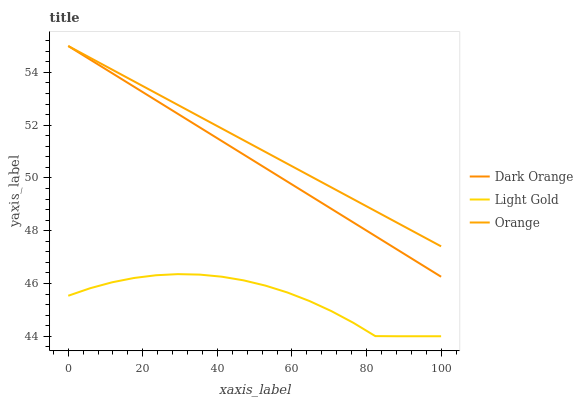Does Light Gold have the minimum area under the curve?
Answer yes or no. Yes. Does Orange have the maximum area under the curve?
Answer yes or no. Yes. Does Dark Orange have the minimum area under the curve?
Answer yes or no. No. Does Dark Orange have the maximum area under the curve?
Answer yes or no. No. Is Orange the smoothest?
Answer yes or no. Yes. Is Light Gold the roughest?
Answer yes or no. Yes. Is Dark Orange the smoothest?
Answer yes or no. No. Is Dark Orange the roughest?
Answer yes or no. No. Does Light Gold have the lowest value?
Answer yes or no. Yes. Does Dark Orange have the lowest value?
Answer yes or no. No. Does Dark Orange have the highest value?
Answer yes or no. Yes. Does Light Gold have the highest value?
Answer yes or no. No. Is Light Gold less than Dark Orange?
Answer yes or no. Yes. Is Orange greater than Light Gold?
Answer yes or no. Yes. Does Orange intersect Dark Orange?
Answer yes or no. Yes. Is Orange less than Dark Orange?
Answer yes or no. No. Is Orange greater than Dark Orange?
Answer yes or no. No. Does Light Gold intersect Dark Orange?
Answer yes or no. No. 